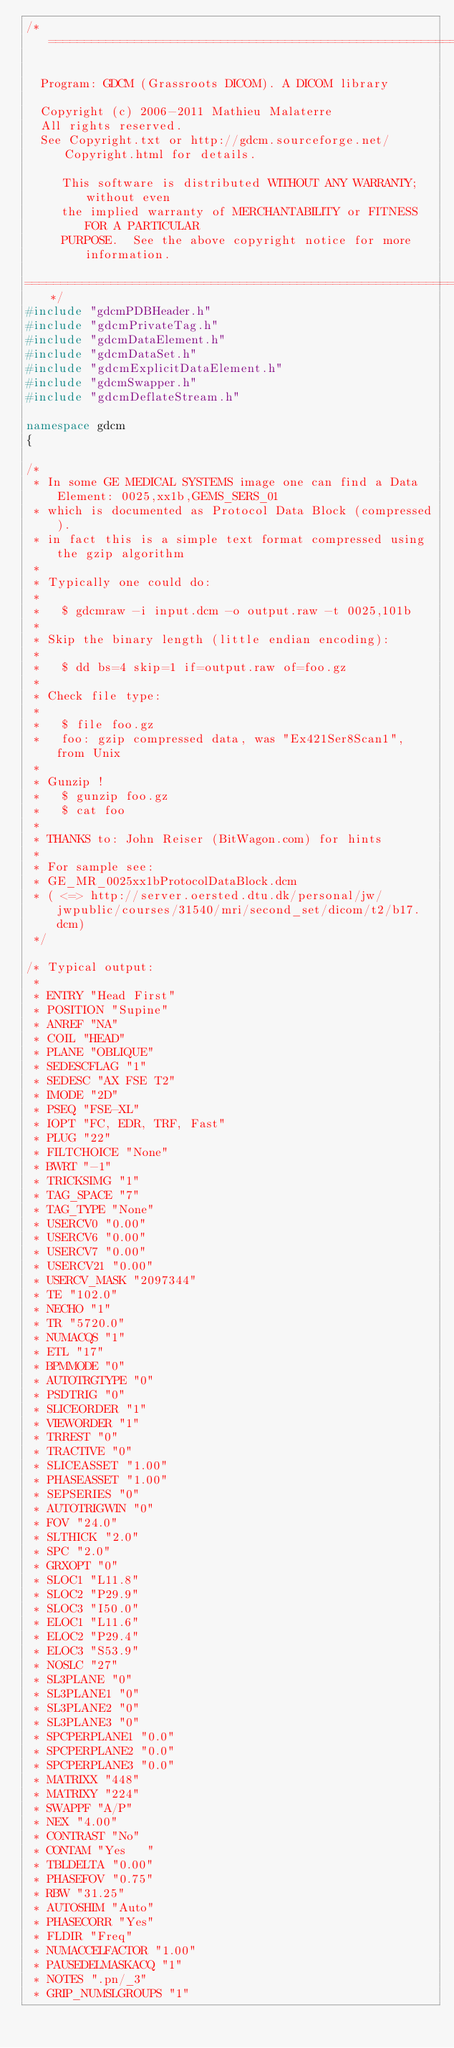Convert code to text. <code><loc_0><loc_0><loc_500><loc_500><_C++_>/*=========================================================================

  Program: GDCM (Grassroots DICOM). A DICOM library

  Copyright (c) 2006-2011 Mathieu Malaterre
  All rights reserved.
  See Copyright.txt or http://gdcm.sourceforge.net/Copyright.html for details.

     This software is distributed WITHOUT ANY WARRANTY; without even
     the implied warranty of MERCHANTABILITY or FITNESS FOR A PARTICULAR
     PURPOSE.  See the above copyright notice for more information.

=========================================================================*/
#include "gdcmPDBHeader.h"
#include "gdcmPrivateTag.h"
#include "gdcmDataElement.h"
#include "gdcmDataSet.h"
#include "gdcmExplicitDataElement.h"
#include "gdcmSwapper.h"
#include "gdcmDeflateStream.h"

namespace gdcm
{

/*
 * In some GE MEDICAL SYSTEMS image one can find a Data Element: 0025,xx1b,GEMS_SERS_01
 * which is documented as Protocol Data Block (compressed).
 * in fact this is a simple text format compressed using the gzip algorithm
 *
 * Typically one could do:
 *
 *   $ gdcmraw -i input.dcm -o output.raw -t 0025,101b
 *
 * Skip the binary length (little endian encoding):
 *
 *   $ dd bs=4 skip=1 if=output.raw of=foo.gz
 *
 * Check file type:
 *
 *   $ file foo.gz
 *   foo: gzip compressed data, was "Ex421Ser8Scan1", from Unix
 *
 * Gunzip !
 *   $ gunzip foo.gz
 *   $ cat foo
 *
 * THANKS to: John Reiser (BitWagon.com) for hints
 *
 * For sample see:
 * GE_MR_0025xx1bProtocolDataBlock.dcm
 * ( <=> http://server.oersted.dtu.dk/personal/jw/jwpublic/courses/31540/mri/second_set/dicom/t2/b17.dcm)
 */

/* Typical output:
 *
 * ENTRY "Head First"
 * POSITION "Supine"
 * ANREF "NA"
 * COIL "HEAD"
 * PLANE "OBLIQUE"
 * SEDESCFLAG "1"
 * SEDESC "AX FSE T2"
 * IMODE "2D"
 * PSEQ "FSE-XL"
 * IOPT "FC, EDR, TRF, Fast"
 * PLUG "22"
 * FILTCHOICE "None"
 * BWRT "-1"
 * TRICKSIMG "1"
 * TAG_SPACE "7"
 * TAG_TYPE "None"
 * USERCV0 "0.00"
 * USERCV6 "0.00"
 * USERCV7 "0.00"
 * USERCV21 "0.00"
 * USERCV_MASK "2097344"
 * TE "102.0"
 * NECHO "1"
 * TR "5720.0"
 * NUMACQS "1"
 * ETL "17"
 * BPMMODE "0"
 * AUTOTRGTYPE "0"
 * PSDTRIG "0"
 * SLICEORDER "1"
 * VIEWORDER "1"
 * TRREST "0"
 * TRACTIVE "0"
 * SLICEASSET "1.00"
 * PHASEASSET "1.00"
 * SEPSERIES "0"
 * AUTOTRIGWIN "0"
 * FOV "24.0"
 * SLTHICK "2.0"
 * SPC "2.0"
 * GRXOPT "0"
 * SLOC1 "L11.8"
 * SLOC2 "P29.9"
 * SLOC3 "I50.0"
 * ELOC1 "L11.6"
 * ELOC2 "P29.4"
 * ELOC3 "S53.9"
 * NOSLC "27"
 * SL3PLANE "0"
 * SL3PLANE1 "0"
 * SL3PLANE2 "0"
 * SL3PLANE3 "0"
 * SPCPERPLANE1 "0.0"
 * SPCPERPLANE2 "0.0"
 * SPCPERPLANE3 "0.0"
 * MATRIXX "448"
 * MATRIXY "224"
 * SWAPPF "A/P"
 * NEX "4.00"
 * CONTRAST "No"
 * CONTAM "Yes   "
 * TBLDELTA "0.00"
 * PHASEFOV "0.75"
 * RBW "31.25"
 * AUTOSHIM "Auto"
 * PHASECORR "Yes"
 * FLDIR "Freq"
 * NUMACCELFACTOR "1.00"
 * PAUSEDELMASKACQ "1"
 * NOTES ".pn/_3"
 * GRIP_NUMSLGROUPS "1"</code> 